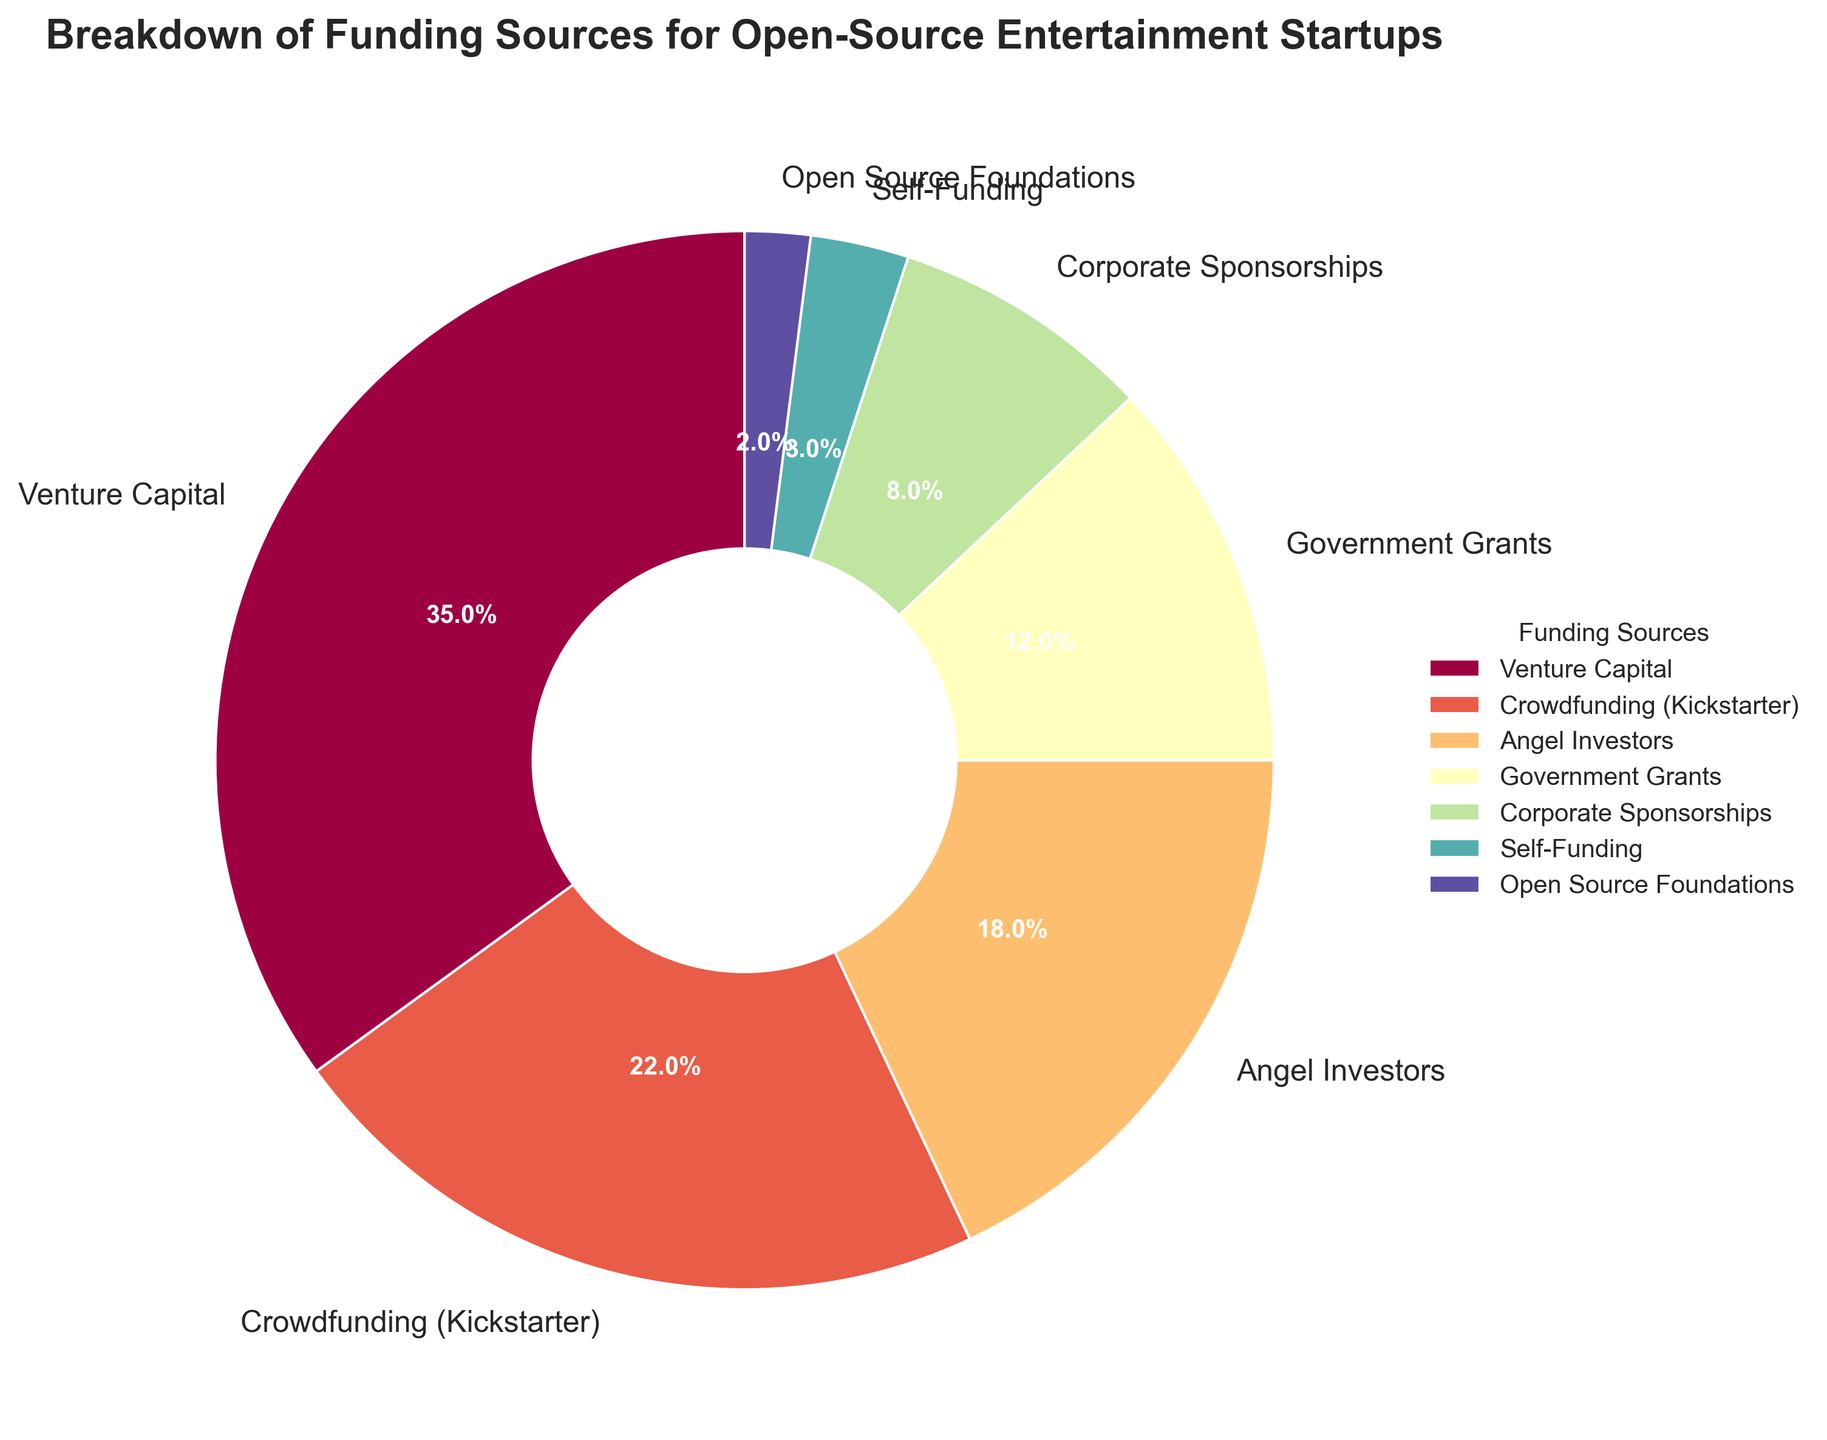What's the primary funding source for open-source entertainment startups? The pie chart's largest segment represents the primary funding source. The biggest wedge displays 35% for Venture Capital.
Answer: Venture Capital Which funding source contributes more, Crowdfunding or Angel Investors? Compare the percentages of the segments labeled Crowdfunding (Kickstarter) and Angel Investors. Crowdfunding is 22%, while Angel Investors is 18%.
Answer: Crowdfunding Which funding sources combined, excluding the top two, contribute less than 25%? List the percentages of funding sources except for the top two (Venture Capital and Crowdfunding). Angel Investors (18%), Government Grants (12%), Corporate Sponsorships (8%), Self-Funding (3%), Open Source Foundations (2%). Sum these: 18 + 12 + 8 + 3 + 2 = 43, so none fit. Re-verify smaller combined sums: Government Grants, Corporate Sponsorships, Self-Funding, Open Source Foundations -> 12 + 8 + 3 + 2 = 25 which equals 25%. Thus Govt Grants + others not fitting. Final valid lower sums (Self-Funding + OSF only are 3+2 = 5%)
Answer: None What are the combined contributions of Government Grants and Corporate Sponsorships? Sum the segments for Government Grants and Corporate Sponsorships (12% and 8%). 12 + 8 = 20%.
Answer: 20% Which funding source is represented by the smallest segment? Identify the segment with the smallest percentage, which is the one labeled 2% for Open Source Foundations.
Answer: Open Source Foundations Is the contribution of Self-Funding more than Corporate Sponsorships? Compare the percentages for Self-Funding (3%) and Corporate Sponsorships (8%).
Answer: No Which two funding sources when combined, equal the contribution of Crowdfunding (Kickstarter)? Find and sum combinations until matching 22%. The valid pair is Angel Investors (18%) + Self-Funding (3%) + Open Source Foundations (2%) to 22% (18+3+1=22%)
Answer: Angel Investors, Self-Funding, Open Source Foundations How much more does Venture Capital contribute than Government Grants? Subtract the percentage of Government Grants from Venture Capital (35% - 12%).
Answer: 23% What is the difference in percentage between the largest and the smallest funding source? Subtract the smallest percentage (2% for Open Source Foundations) from the largest (35% for Venture Capital). 35 - 2 = 33%.
Answer: 33% 